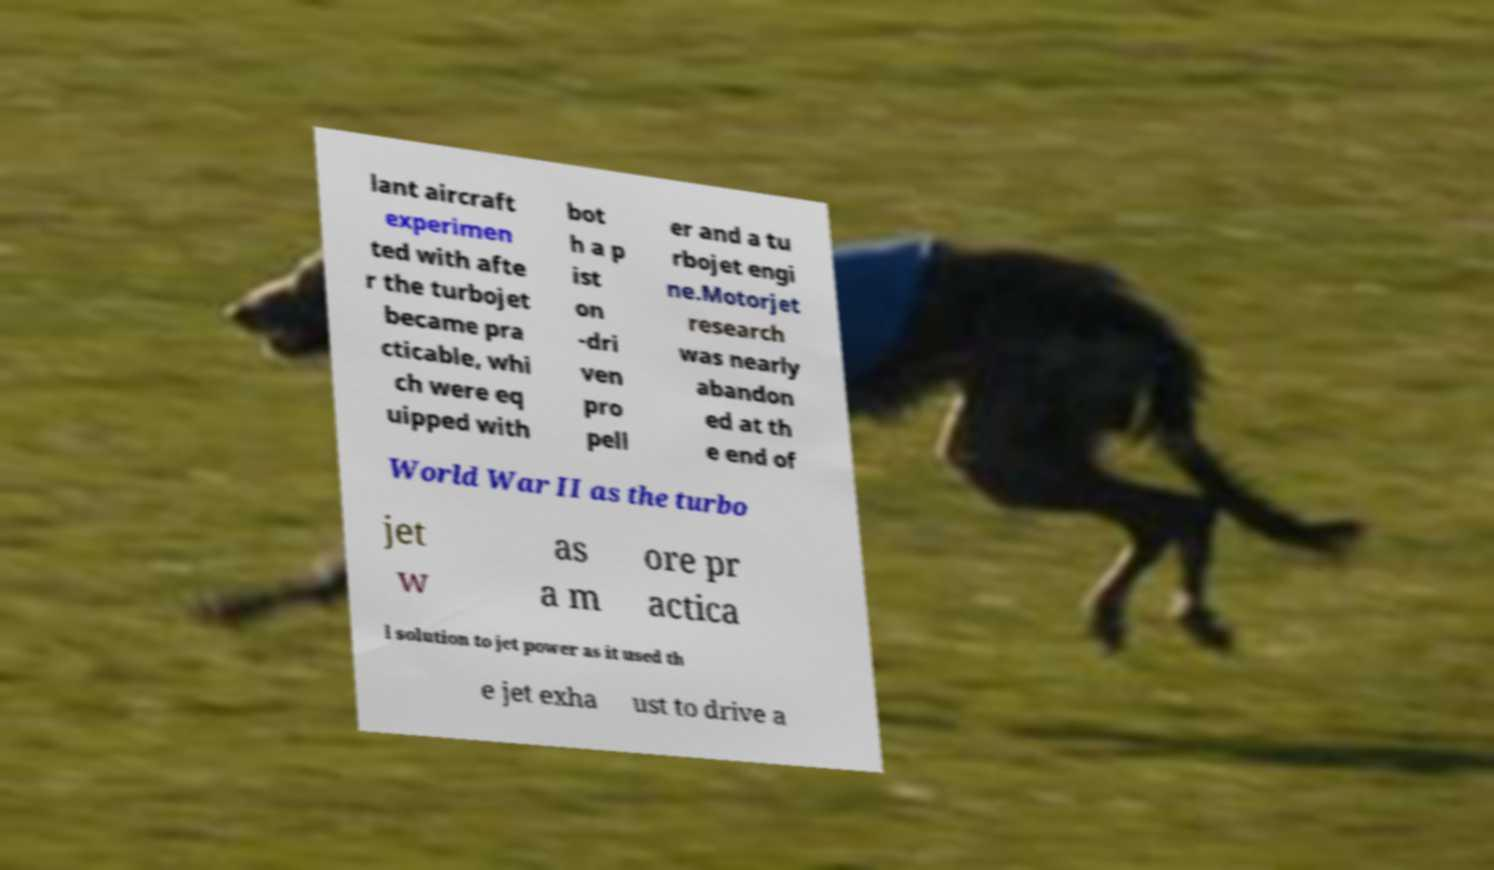I need the written content from this picture converted into text. Can you do that? lant aircraft experimen ted with afte r the turbojet became pra cticable, whi ch were eq uipped with bot h a p ist on -dri ven pro pell er and a tu rbojet engi ne.Motorjet research was nearly abandon ed at th e end of World War II as the turbo jet w as a m ore pr actica l solution to jet power as it used th e jet exha ust to drive a 